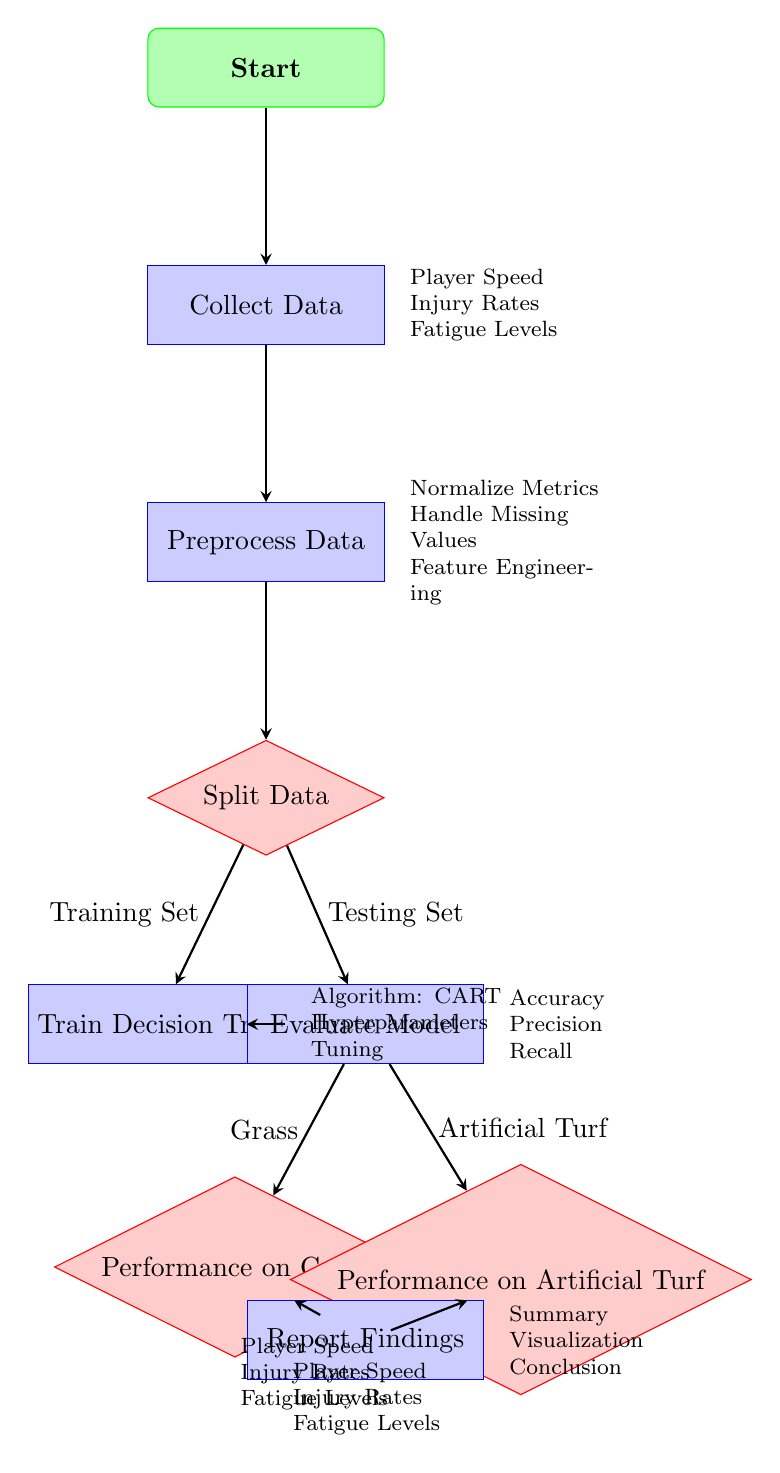What is the first step in the diagram? The first step is labeled as "Start." It is the initial node in the flow of the procedure outlined in the diagram.
Answer: Start How many decision nodes are present in the diagram? There are four decision nodes: "Split Data," "Performance on Grass," and "Performance on Artificial Turf." Each decision node indicates a point where the flow of the process can diverge based on certain criteria.
Answer: Four What type of model is being trained in the diagram? The model being trained is a "Decision Tree." This is explicitly noted in the process labeled "Train Decision Tree."
Answer: Decision Tree What metrics are evaluated after the model is trained? The metrics evaluated are "Accuracy," "Precision," and "Recall." These outcomes are listed in the node connected to the "Evaluate Model" process.
Answer: Accuracy, Precision, Recall What data preprocessing steps are mentioned in the diagram? The preprocessing steps mentioned are "Normalize Metrics," "Handle Missing Values," and "Feature Engineering." These are associated with the "Preprocess Data" process node.
Answer: Normalize Metrics, Handle Missing Values, Feature Engineering What are the performance metrics compared for each playing surface? The metrics compared for both playing surfaces are "Player Speed," "Injury Rates," and "Fatigue Levels." These indicators are listed beneath both the "Performance on Grass" and "Performance on Artificial Turf" nodes.
Answer: Player Speed, Injury Rates, Fatigue Levels What follows the evaluation of the model? After the evaluation of the model, the next step is to "Report Findings." This step synthesizes the results and presents the conclusions drawn from the model's performance.
Answer: Report Findings What is the arrow direction indicating the training set in the diagram? The arrow indicating the training set extends from the "Split Data" decision node to the "Train Decision Tree" process. This indicates that the training set flows into the model training step.
Answer: Training Set Which process comes after data collection? The process that follows "Collect Data" is "Preprocess Data." This indicates that data needs to be processed before being used for modeling.
Answer: Preprocess Data 